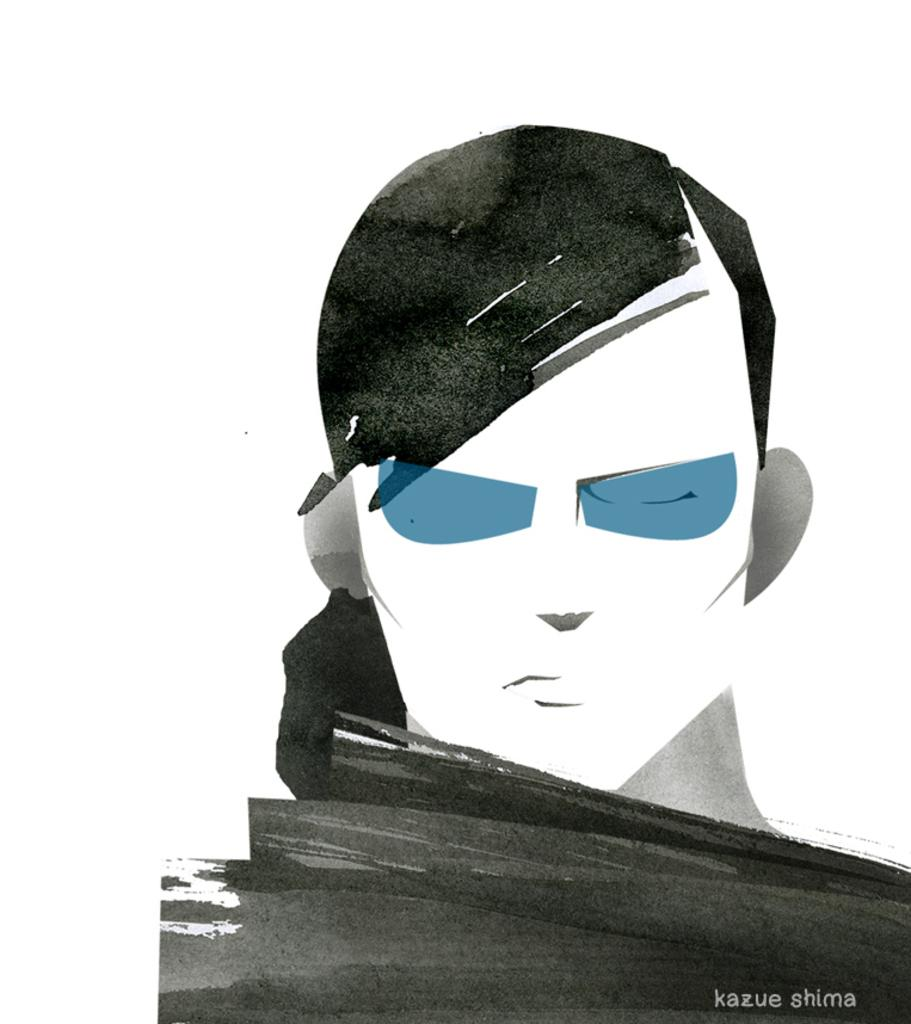What is the main subject of the image? The main subject of the image is a sketch of a person. What type of plants can be seen growing in the cave in the image? There is no cave or plants present in the image; it features a sketch of a person. 